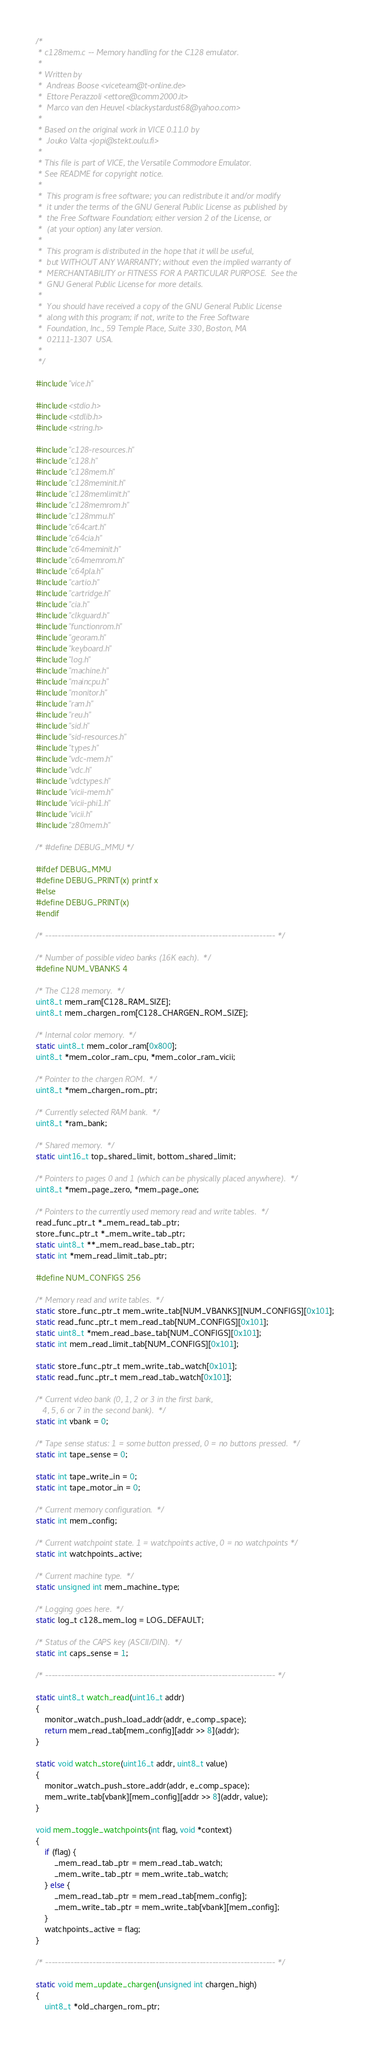<code> <loc_0><loc_0><loc_500><loc_500><_C_>/*
 * c128mem.c -- Memory handling for the C128 emulator.
 *
 * Written by
 *  Andreas Boose <viceteam@t-online.de>
 *  Ettore Perazzoli <ettore@comm2000.it>
 *  Marco van den Heuvel <blackystardust68@yahoo.com>
 *
 * Based on the original work in VICE 0.11.0 by
 *  Jouko Valta <jopi@stekt.oulu.fi>
 *
 * This file is part of VICE, the Versatile Commodore Emulator.
 * See README for copyright notice.
 *
 *  This program is free software; you can redistribute it and/or modify
 *  it under the terms of the GNU General Public License as published by
 *  the Free Software Foundation; either version 2 of the License, or
 *  (at your option) any later version.
 *
 *  This program is distributed in the hope that it will be useful,
 *  but WITHOUT ANY WARRANTY; without even the implied warranty of
 *  MERCHANTABILITY or FITNESS FOR A PARTICULAR PURPOSE.  See the
 *  GNU General Public License for more details.
 *
 *  You should have received a copy of the GNU General Public License
 *  along with this program; if not, write to the Free Software
 *  Foundation, Inc., 59 Temple Place, Suite 330, Boston, MA
 *  02111-1307  USA.
 *
 */

#include "vice.h"

#include <stdio.h>
#include <stdlib.h>
#include <string.h>

#include "c128-resources.h"
#include "c128.h"
#include "c128mem.h"
#include "c128meminit.h"
#include "c128memlimit.h"
#include "c128memrom.h"
#include "c128mmu.h"
#include "c64cart.h"
#include "c64cia.h"
#include "c64meminit.h"
#include "c64memrom.h"
#include "c64pla.h"
#include "cartio.h"
#include "cartridge.h"
#include "cia.h"
#include "clkguard.h"
#include "functionrom.h"
#include "georam.h"
#include "keyboard.h"
#include "log.h"
#include "machine.h"
#include "maincpu.h"
#include "monitor.h"
#include "ram.h"
#include "reu.h"
#include "sid.h"
#include "sid-resources.h"
#include "types.h"
#include "vdc-mem.h"
#include "vdc.h"
#include "vdctypes.h"
#include "vicii-mem.h"
#include "vicii-phi1.h"
#include "vicii.h"
#include "z80mem.h"

/* #define DEBUG_MMU */

#ifdef DEBUG_MMU
#define DEBUG_PRINT(x) printf x
#else
#define DEBUG_PRINT(x)
#endif

/* ------------------------------------------------------------------------- */

/* Number of possible video banks (16K each).  */
#define NUM_VBANKS 4

/* The C128 memory.  */
uint8_t mem_ram[C128_RAM_SIZE];
uint8_t mem_chargen_rom[C128_CHARGEN_ROM_SIZE];

/* Internal color memory.  */
static uint8_t mem_color_ram[0x800];
uint8_t *mem_color_ram_cpu, *mem_color_ram_vicii;

/* Pointer to the chargen ROM.  */
uint8_t *mem_chargen_rom_ptr;

/* Currently selected RAM bank.  */
uint8_t *ram_bank;

/* Shared memory.  */
static uint16_t top_shared_limit, bottom_shared_limit;

/* Pointers to pages 0 and 1 (which can be physically placed anywhere).  */
uint8_t *mem_page_zero, *mem_page_one;

/* Pointers to the currently used memory read and write tables.  */
read_func_ptr_t *_mem_read_tab_ptr;
store_func_ptr_t *_mem_write_tab_ptr;
static uint8_t **_mem_read_base_tab_ptr;
static int *mem_read_limit_tab_ptr;

#define NUM_CONFIGS 256

/* Memory read and write tables.  */
static store_func_ptr_t mem_write_tab[NUM_VBANKS][NUM_CONFIGS][0x101];
static read_func_ptr_t mem_read_tab[NUM_CONFIGS][0x101];
static uint8_t *mem_read_base_tab[NUM_CONFIGS][0x101];
static int mem_read_limit_tab[NUM_CONFIGS][0x101];

static store_func_ptr_t mem_write_tab_watch[0x101];
static read_func_ptr_t mem_read_tab_watch[0x101];

/* Current video bank (0, 1, 2 or 3 in the first bank,
   4, 5, 6 or 7 in the second bank).  */
static int vbank = 0;

/* Tape sense status: 1 = some button pressed, 0 = no buttons pressed.  */
static int tape_sense = 0;

static int tape_write_in = 0;
static int tape_motor_in = 0;

/* Current memory configuration.  */
static int mem_config;

/* Current watchpoint state. 1 = watchpoints active, 0 = no watchpoints */
static int watchpoints_active;

/* Current machine type.  */
static unsigned int mem_machine_type;

/* Logging goes here.  */
static log_t c128_mem_log = LOG_DEFAULT;

/* Status of the CAPS key (ASCII/DIN).  */
static int caps_sense = 1;

/* ------------------------------------------------------------------------- */

static uint8_t watch_read(uint16_t addr)
{
    monitor_watch_push_load_addr(addr, e_comp_space);
    return mem_read_tab[mem_config][addr >> 8](addr);
}

static void watch_store(uint16_t addr, uint8_t value)
{
    monitor_watch_push_store_addr(addr, e_comp_space);
    mem_write_tab[vbank][mem_config][addr >> 8](addr, value);
}

void mem_toggle_watchpoints(int flag, void *context)
{
    if (flag) {
        _mem_read_tab_ptr = mem_read_tab_watch;
        _mem_write_tab_ptr = mem_write_tab_watch;
    } else {
        _mem_read_tab_ptr = mem_read_tab[mem_config];
        _mem_write_tab_ptr = mem_write_tab[vbank][mem_config];
    }
    watchpoints_active = flag;
}

/* ------------------------------------------------------------------------- */

static void mem_update_chargen(unsigned int chargen_high)
{
    uint8_t *old_chargen_rom_ptr;
</code> 